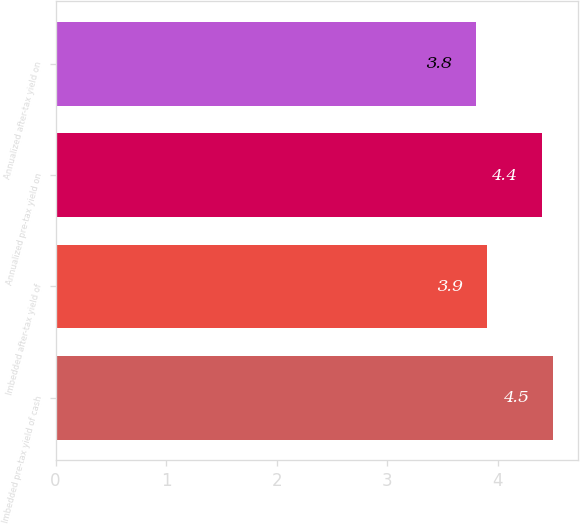<chart> <loc_0><loc_0><loc_500><loc_500><bar_chart><fcel>Imbedded pre-tax yield of cash<fcel>Imbedded after-tax yield of<fcel>Annualized pre-tax yield on<fcel>Annualized after-tax yield on<nl><fcel>4.5<fcel>3.9<fcel>4.4<fcel>3.8<nl></chart> 